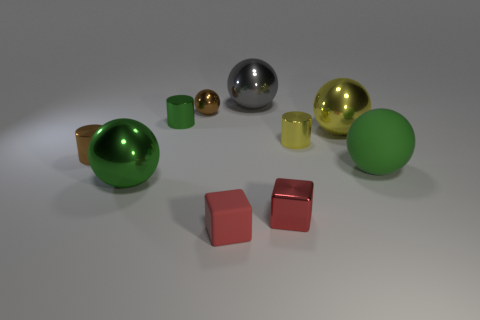Subtract all small brown metallic cylinders. How many cylinders are left? 2 Subtract all green cylinders. How many cylinders are left? 2 Subtract all cylinders. How many objects are left? 7 Subtract 1 spheres. How many spheres are left? 4 Subtract all yellow spheres. Subtract all gray cylinders. How many spheres are left? 4 Subtract all red cylinders. How many green balls are left? 2 Subtract all tiny shiny cylinders. Subtract all small green cylinders. How many objects are left? 6 Add 9 big gray things. How many big gray things are left? 10 Add 2 tiny yellow rubber balls. How many tiny yellow rubber balls exist? 2 Subtract 0 cyan cylinders. How many objects are left? 10 